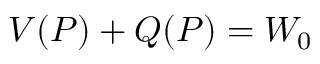<formula> <loc_0><loc_0><loc_500><loc_500>\begin{array} { r } { V ( P ) + Q ( P ) = W _ { 0 } } \end{array}</formula> 